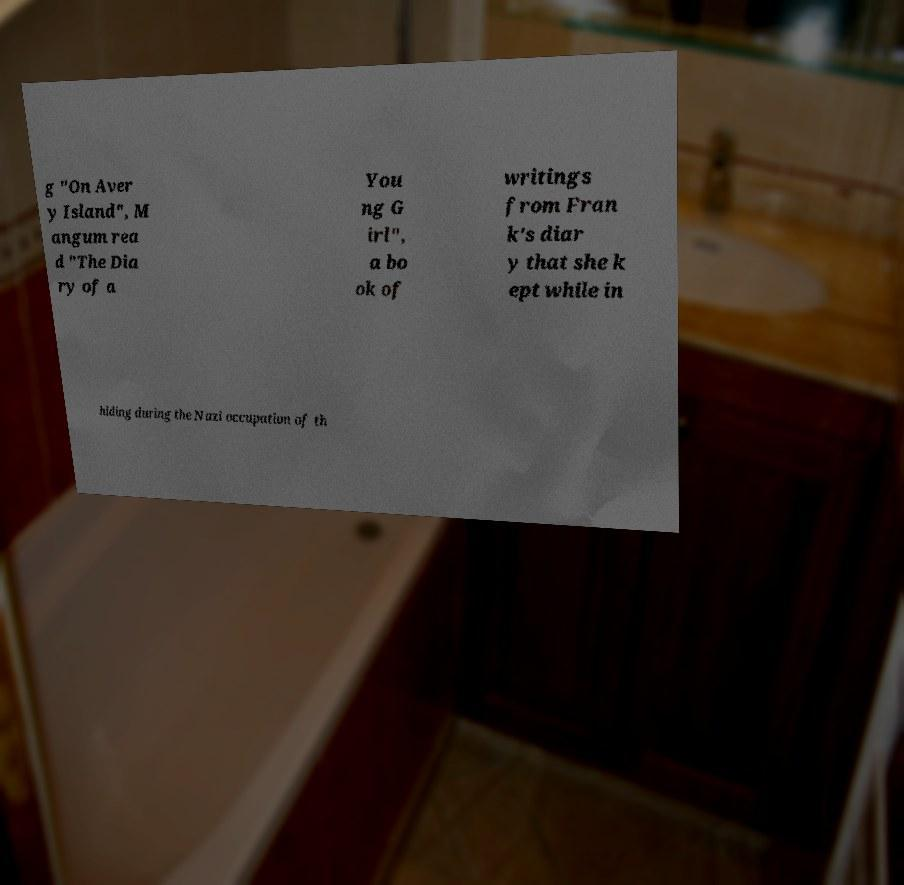For documentation purposes, I need the text within this image transcribed. Could you provide that? g "On Aver y Island", M angum rea d "The Dia ry of a You ng G irl", a bo ok of writings from Fran k's diar y that she k ept while in hiding during the Nazi occupation of th 